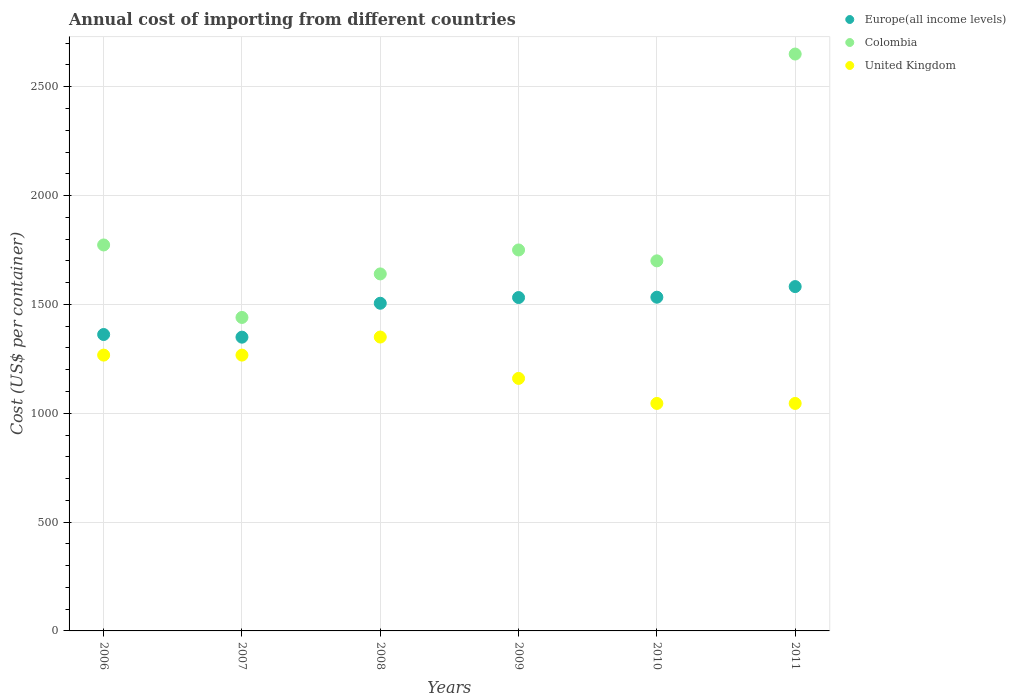How many different coloured dotlines are there?
Offer a very short reply. 3. Is the number of dotlines equal to the number of legend labels?
Your answer should be compact. Yes. What is the total annual cost of importing in Europe(all income levels) in 2009?
Make the answer very short. 1531.44. Across all years, what is the maximum total annual cost of importing in United Kingdom?
Provide a short and direct response. 1350. Across all years, what is the minimum total annual cost of importing in United Kingdom?
Keep it short and to the point. 1045. In which year was the total annual cost of importing in Colombia minimum?
Make the answer very short. 2007. What is the total total annual cost of importing in Europe(all income levels) in the graph?
Make the answer very short. 8862.38. What is the difference between the total annual cost of importing in Colombia in 2006 and that in 2011?
Keep it short and to the point. -877. What is the difference between the total annual cost of importing in United Kingdom in 2009 and the total annual cost of importing in Europe(all income levels) in 2007?
Give a very brief answer. -189.41. What is the average total annual cost of importing in Colombia per year?
Offer a terse response. 1825.5. In the year 2009, what is the difference between the total annual cost of importing in Europe(all income levels) and total annual cost of importing in United Kingdom?
Your answer should be very brief. 371.44. In how many years, is the total annual cost of importing in United Kingdom greater than 2000 US$?
Your answer should be compact. 0. What is the ratio of the total annual cost of importing in United Kingdom in 2008 to that in 2009?
Provide a succinct answer. 1.16. Is the total annual cost of importing in Europe(all income levels) in 2006 less than that in 2010?
Provide a short and direct response. Yes. What is the difference between the highest and the second highest total annual cost of importing in United Kingdom?
Provide a short and direct response. 83. What is the difference between the highest and the lowest total annual cost of importing in Europe(all income levels)?
Ensure brevity in your answer.  232.36. In how many years, is the total annual cost of importing in Colombia greater than the average total annual cost of importing in Colombia taken over all years?
Make the answer very short. 1. Does the total annual cost of importing in United Kingdom monotonically increase over the years?
Ensure brevity in your answer.  No. Is the total annual cost of importing in Europe(all income levels) strictly greater than the total annual cost of importing in Colombia over the years?
Make the answer very short. No. How many dotlines are there?
Offer a very short reply. 3. Where does the legend appear in the graph?
Keep it short and to the point. Top right. What is the title of the graph?
Ensure brevity in your answer.  Annual cost of importing from different countries. Does "Bolivia" appear as one of the legend labels in the graph?
Ensure brevity in your answer.  No. What is the label or title of the Y-axis?
Your response must be concise. Cost (US$ per container). What is the Cost (US$ per container) of Europe(all income levels) in 2006?
Keep it short and to the point. 1361.61. What is the Cost (US$ per container) of Colombia in 2006?
Provide a succinct answer. 1773. What is the Cost (US$ per container) in United Kingdom in 2006?
Keep it short and to the point. 1267. What is the Cost (US$ per container) of Europe(all income levels) in 2007?
Provide a succinct answer. 1349.41. What is the Cost (US$ per container) of Colombia in 2007?
Provide a succinct answer. 1440. What is the Cost (US$ per container) of United Kingdom in 2007?
Keep it short and to the point. 1267. What is the Cost (US$ per container) in Europe(all income levels) in 2008?
Make the answer very short. 1505.17. What is the Cost (US$ per container) in Colombia in 2008?
Make the answer very short. 1640. What is the Cost (US$ per container) in United Kingdom in 2008?
Give a very brief answer. 1350. What is the Cost (US$ per container) in Europe(all income levels) in 2009?
Offer a terse response. 1531.44. What is the Cost (US$ per container) of Colombia in 2009?
Give a very brief answer. 1750. What is the Cost (US$ per container) in United Kingdom in 2009?
Offer a terse response. 1160. What is the Cost (US$ per container) of Europe(all income levels) in 2010?
Make the answer very short. 1532.98. What is the Cost (US$ per container) of Colombia in 2010?
Your answer should be compact. 1700. What is the Cost (US$ per container) in United Kingdom in 2010?
Your response must be concise. 1045. What is the Cost (US$ per container) in Europe(all income levels) in 2011?
Provide a short and direct response. 1581.77. What is the Cost (US$ per container) in Colombia in 2011?
Provide a succinct answer. 2650. What is the Cost (US$ per container) of United Kingdom in 2011?
Give a very brief answer. 1045. Across all years, what is the maximum Cost (US$ per container) in Europe(all income levels)?
Your response must be concise. 1581.77. Across all years, what is the maximum Cost (US$ per container) of Colombia?
Keep it short and to the point. 2650. Across all years, what is the maximum Cost (US$ per container) in United Kingdom?
Offer a terse response. 1350. Across all years, what is the minimum Cost (US$ per container) of Europe(all income levels)?
Ensure brevity in your answer.  1349.41. Across all years, what is the minimum Cost (US$ per container) of Colombia?
Provide a succinct answer. 1440. Across all years, what is the minimum Cost (US$ per container) of United Kingdom?
Your answer should be very brief. 1045. What is the total Cost (US$ per container) in Europe(all income levels) in the graph?
Your response must be concise. 8862.38. What is the total Cost (US$ per container) of Colombia in the graph?
Provide a succinct answer. 1.10e+04. What is the total Cost (US$ per container) of United Kingdom in the graph?
Offer a terse response. 7134. What is the difference between the Cost (US$ per container) of Europe(all income levels) in 2006 and that in 2007?
Offer a very short reply. 12.2. What is the difference between the Cost (US$ per container) in Colombia in 2006 and that in 2007?
Offer a terse response. 333. What is the difference between the Cost (US$ per container) in United Kingdom in 2006 and that in 2007?
Your answer should be compact. 0. What is the difference between the Cost (US$ per container) of Europe(all income levels) in 2006 and that in 2008?
Offer a terse response. -143.56. What is the difference between the Cost (US$ per container) in Colombia in 2006 and that in 2008?
Offer a terse response. 133. What is the difference between the Cost (US$ per container) of United Kingdom in 2006 and that in 2008?
Offer a terse response. -83. What is the difference between the Cost (US$ per container) in Europe(all income levels) in 2006 and that in 2009?
Your answer should be very brief. -169.83. What is the difference between the Cost (US$ per container) of United Kingdom in 2006 and that in 2009?
Your answer should be very brief. 107. What is the difference between the Cost (US$ per container) in Europe(all income levels) in 2006 and that in 2010?
Ensure brevity in your answer.  -171.37. What is the difference between the Cost (US$ per container) of United Kingdom in 2006 and that in 2010?
Ensure brevity in your answer.  222. What is the difference between the Cost (US$ per container) in Europe(all income levels) in 2006 and that in 2011?
Your answer should be very brief. -220.16. What is the difference between the Cost (US$ per container) in Colombia in 2006 and that in 2011?
Keep it short and to the point. -877. What is the difference between the Cost (US$ per container) of United Kingdom in 2006 and that in 2011?
Provide a short and direct response. 222. What is the difference between the Cost (US$ per container) in Europe(all income levels) in 2007 and that in 2008?
Your response must be concise. -155.76. What is the difference between the Cost (US$ per container) of Colombia in 2007 and that in 2008?
Offer a very short reply. -200. What is the difference between the Cost (US$ per container) in United Kingdom in 2007 and that in 2008?
Your answer should be very brief. -83. What is the difference between the Cost (US$ per container) of Europe(all income levels) in 2007 and that in 2009?
Offer a terse response. -182.02. What is the difference between the Cost (US$ per container) in Colombia in 2007 and that in 2009?
Keep it short and to the point. -310. What is the difference between the Cost (US$ per container) in United Kingdom in 2007 and that in 2009?
Your response must be concise. 107. What is the difference between the Cost (US$ per container) of Europe(all income levels) in 2007 and that in 2010?
Your answer should be compact. -183.57. What is the difference between the Cost (US$ per container) of Colombia in 2007 and that in 2010?
Provide a short and direct response. -260. What is the difference between the Cost (US$ per container) of United Kingdom in 2007 and that in 2010?
Keep it short and to the point. 222. What is the difference between the Cost (US$ per container) of Europe(all income levels) in 2007 and that in 2011?
Provide a succinct answer. -232.36. What is the difference between the Cost (US$ per container) of Colombia in 2007 and that in 2011?
Give a very brief answer. -1210. What is the difference between the Cost (US$ per container) of United Kingdom in 2007 and that in 2011?
Your answer should be compact. 222. What is the difference between the Cost (US$ per container) in Europe(all income levels) in 2008 and that in 2009?
Provide a short and direct response. -26.27. What is the difference between the Cost (US$ per container) of Colombia in 2008 and that in 2009?
Provide a succinct answer. -110. What is the difference between the Cost (US$ per container) of United Kingdom in 2008 and that in 2009?
Provide a succinct answer. 190. What is the difference between the Cost (US$ per container) in Europe(all income levels) in 2008 and that in 2010?
Offer a terse response. -27.81. What is the difference between the Cost (US$ per container) of Colombia in 2008 and that in 2010?
Your answer should be compact. -60. What is the difference between the Cost (US$ per container) of United Kingdom in 2008 and that in 2010?
Keep it short and to the point. 305. What is the difference between the Cost (US$ per container) of Europe(all income levels) in 2008 and that in 2011?
Provide a short and direct response. -76.6. What is the difference between the Cost (US$ per container) of Colombia in 2008 and that in 2011?
Your answer should be compact. -1010. What is the difference between the Cost (US$ per container) of United Kingdom in 2008 and that in 2011?
Offer a very short reply. 305. What is the difference between the Cost (US$ per container) in Europe(all income levels) in 2009 and that in 2010?
Make the answer very short. -1.54. What is the difference between the Cost (US$ per container) of United Kingdom in 2009 and that in 2010?
Make the answer very short. 115. What is the difference between the Cost (US$ per container) of Europe(all income levels) in 2009 and that in 2011?
Your answer should be compact. -50.33. What is the difference between the Cost (US$ per container) of Colombia in 2009 and that in 2011?
Ensure brevity in your answer.  -900. What is the difference between the Cost (US$ per container) of United Kingdom in 2009 and that in 2011?
Offer a very short reply. 115. What is the difference between the Cost (US$ per container) in Europe(all income levels) in 2010 and that in 2011?
Your response must be concise. -48.79. What is the difference between the Cost (US$ per container) of Colombia in 2010 and that in 2011?
Make the answer very short. -950. What is the difference between the Cost (US$ per container) in Europe(all income levels) in 2006 and the Cost (US$ per container) in Colombia in 2007?
Give a very brief answer. -78.39. What is the difference between the Cost (US$ per container) in Europe(all income levels) in 2006 and the Cost (US$ per container) in United Kingdom in 2007?
Ensure brevity in your answer.  94.61. What is the difference between the Cost (US$ per container) of Colombia in 2006 and the Cost (US$ per container) of United Kingdom in 2007?
Give a very brief answer. 506. What is the difference between the Cost (US$ per container) of Europe(all income levels) in 2006 and the Cost (US$ per container) of Colombia in 2008?
Offer a terse response. -278.39. What is the difference between the Cost (US$ per container) of Europe(all income levels) in 2006 and the Cost (US$ per container) of United Kingdom in 2008?
Make the answer very short. 11.61. What is the difference between the Cost (US$ per container) of Colombia in 2006 and the Cost (US$ per container) of United Kingdom in 2008?
Your answer should be compact. 423. What is the difference between the Cost (US$ per container) of Europe(all income levels) in 2006 and the Cost (US$ per container) of Colombia in 2009?
Offer a very short reply. -388.39. What is the difference between the Cost (US$ per container) of Europe(all income levels) in 2006 and the Cost (US$ per container) of United Kingdom in 2009?
Your answer should be very brief. 201.61. What is the difference between the Cost (US$ per container) in Colombia in 2006 and the Cost (US$ per container) in United Kingdom in 2009?
Ensure brevity in your answer.  613. What is the difference between the Cost (US$ per container) in Europe(all income levels) in 2006 and the Cost (US$ per container) in Colombia in 2010?
Provide a succinct answer. -338.39. What is the difference between the Cost (US$ per container) of Europe(all income levels) in 2006 and the Cost (US$ per container) of United Kingdom in 2010?
Provide a short and direct response. 316.61. What is the difference between the Cost (US$ per container) of Colombia in 2006 and the Cost (US$ per container) of United Kingdom in 2010?
Provide a succinct answer. 728. What is the difference between the Cost (US$ per container) of Europe(all income levels) in 2006 and the Cost (US$ per container) of Colombia in 2011?
Offer a terse response. -1288.39. What is the difference between the Cost (US$ per container) in Europe(all income levels) in 2006 and the Cost (US$ per container) in United Kingdom in 2011?
Your answer should be compact. 316.61. What is the difference between the Cost (US$ per container) in Colombia in 2006 and the Cost (US$ per container) in United Kingdom in 2011?
Keep it short and to the point. 728. What is the difference between the Cost (US$ per container) in Europe(all income levels) in 2007 and the Cost (US$ per container) in Colombia in 2008?
Your response must be concise. -290.59. What is the difference between the Cost (US$ per container) in Europe(all income levels) in 2007 and the Cost (US$ per container) in United Kingdom in 2008?
Your response must be concise. -0.59. What is the difference between the Cost (US$ per container) in Europe(all income levels) in 2007 and the Cost (US$ per container) in Colombia in 2009?
Ensure brevity in your answer.  -400.59. What is the difference between the Cost (US$ per container) in Europe(all income levels) in 2007 and the Cost (US$ per container) in United Kingdom in 2009?
Offer a terse response. 189.41. What is the difference between the Cost (US$ per container) of Colombia in 2007 and the Cost (US$ per container) of United Kingdom in 2009?
Give a very brief answer. 280. What is the difference between the Cost (US$ per container) in Europe(all income levels) in 2007 and the Cost (US$ per container) in Colombia in 2010?
Offer a very short reply. -350.59. What is the difference between the Cost (US$ per container) in Europe(all income levels) in 2007 and the Cost (US$ per container) in United Kingdom in 2010?
Keep it short and to the point. 304.41. What is the difference between the Cost (US$ per container) in Colombia in 2007 and the Cost (US$ per container) in United Kingdom in 2010?
Ensure brevity in your answer.  395. What is the difference between the Cost (US$ per container) in Europe(all income levels) in 2007 and the Cost (US$ per container) in Colombia in 2011?
Give a very brief answer. -1300.59. What is the difference between the Cost (US$ per container) of Europe(all income levels) in 2007 and the Cost (US$ per container) of United Kingdom in 2011?
Offer a very short reply. 304.41. What is the difference between the Cost (US$ per container) in Colombia in 2007 and the Cost (US$ per container) in United Kingdom in 2011?
Make the answer very short. 395. What is the difference between the Cost (US$ per container) of Europe(all income levels) in 2008 and the Cost (US$ per container) of Colombia in 2009?
Ensure brevity in your answer.  -244.83. What is the difference between the Cost (US$ per container) in Europe(all income levels) in 2008 and the Cost (US$ per container) in United Kingdom in 2009?
Keep it short and to the point. 345.17. What is the difference between the Cost (US$ per container) in Colombia in 2008 and the Cost (US$ per container) in United Kingdom in 2009?
Provide a succinct answer. 480. What is the difference between the Cost (US$ per container) of Europe(all income levels) in 2008 and the Cost (US$ per container) of Colombia in 2010?
Ensure brevity in your answer.  -194.83. What is the difference between the Cost (US$ per container) in Europe(all income levels) in 2008 and the Cost (US$ per container) in United Kingdom in 2010?
Ensure brevity in your answer.  460.17. What is the difference between the Cost (US$ per container) in Colombia in 2008 and the Cost (US$ per container) in United Kingdom in 2010?
Ensure brevity in your answer.  595. What is the difference between the Cost (US$ per container) in Europe(all income levels) in 2008 and the Cost (US$ per container) in Colombia in 2011?
Ensure brevity in your answer.  -1144.83. What is the difference between the Cost (US$ per container) of Europe(all income levels) in 2008 and the Cost (US$ per container) of United Kingdom in 2011?
Offer a very short reply. 460.17. What is the difference between the Cost (US$ per container) in Colombia in 2008 and the Cost (US$ per container) in United Kingdom in 2011?
Make the answer very short. 595. What is the difference between the Cost (US$ per container) in Europe(all income levels) in 2009 and the Cost (US$ per container) in Colombia in 2010?
Ensure brevity in your answer.  -168.56. What is the difference between the Cost (US$ per container) of Europe(all income levels) in 2009 and the Cost (US$ per container) of United Kingdom in 2010?
Provide a succinct answer. 486.44. What is the difference between the Cost (US$ per container) of Colombia in 2009 and the Cost (US$ per container) of United Kingdom in 2010?
Give a very brief answer. 705. What is the difference between the Cost (US$ per container) in Europe(all income levels) in 2009 and the Cost (US$ per container) in Colombia in 2011?
Give a very brief answer. -1118.56. What is the difference between the Cost (US$ per container) in Europe(all income levels) in 2009 and the Cost (US$ per container) in United Kingdom in 2011?
Provide a short and direct response. 486.44. What is the difference between the Cost (US$ per container) of Colombia in 2009 and the Cost (US$ per container) of United Kingdom in 2011?
Make the answer very short. 705. What is the difference between the Cost (US$ per container) in Europe(all income levels) in 2010 and the Cost (US$ per container) in Colombia in 2011?
Your answer should be compact. -1117.02. What is the difference between the Cost (US$ per container) of Europe(all income levels) in 2010 and the Cost (US$ per container) of United Kingdom in 2011?
Provide a short and direct response. 487.98. What is the difference between the Cost (US$ per container) in Colombia in 2010 and the Cost (US$ per container) in United Kingdom in 2011?
Provide a succinct answer. 655. What is the average Cost (US$ per container) of Europe(all income levels) per year?
Provide a short and direct response. 1477.06. What is the average Cost (US$ per container) in Colombia per year?
Offer a terse response. 1825.5. What is the average Cost (US$ per container) of United Kingdom per year?
Make the answer very short. 1189. In the year 2006, what is the difference between the Cost (US$ per container) of Europe(all income levels) and Cost (US$ per container) of Colombia?
Provide a succinct answer. -411.39. In the year 2006, what is the difference between the Cost (US$ per container) in Europe(all income levels) and Cost (US$ per container) in United Kingdom?
Provide a succinct answer. 94.61. In the year 2006, what is the difference between the Cost (US$ per container) in Colombia and Cost (US$ per container) in United Kingdom?
Offer a terse response. 506. In the year 2007, what is the difference between the Cost (US$ per container) in Europe(all income levels) and Cost (US$ per container) in Colombia?
Make the answer very short. -90.59. In the year 2007, what is the difference between the Cost (US$ per container) of Europe(all income levels) and Cost (US$ per container) of United Kingdom?
Provide a short and direct response. 82.41. In the year 2007, what is the difference between the Cost (US$ per container) of Colombia and Cost (US$ per container) of United Kingdom?
Offer a terse response. 173. In the year 2008, what is the difference between the Cost (US$ per container) of Europe(all income levels) and Cost (US$ per container) of Colombia?
Ensure brevity in your answer.  -134.83. In the year 2008, what is the difference between the Cost (US$ per container) in Europe(all income levels) and Cost (US$ per container) in United Kingdom?
Your answer should be compact. 155.17. In the year 2008, what is the difference between the Cost (US$ per container) in Colombia and Cost (US$ per container) in United Kingdom?
Provide a succinct answer. 290. In the year 2009, what is the difference between the Cost (US$ per container) of Europe(all income levels) and Cost (US$ per container) of Colombia?
Provide a short and direct response. -218.56. In the year 2009, what is the difference between the Cost (US$ per container) of Europe(all income levels) and Cost (US$ per container) of United Kingdom?
Offer a very short reply. 371.44. In the year 2009, what is the difference between the Cost (US$ per container) in Colombia and Cost (US$ per container) in United Kingdom?
Keep it short and to the point. 590. In the year 2010, what is the difference between the Cost (US$ per container) of Europe(all income levels) and Cost (US$ per container) of Colombia?
Offer a terse response. -167.02. In the year 2010, what is the difference between the Cost (US$ per container) of Europe(all income levels) and Cost (US$ per container) of United Kingdom?
Your response must be concise. 487.98. In the year 2010, what is the difference between the Cost (US$ per container) of Colombia and Cost (US$ per container) of United Kingdom?
Your response must be concise. 655. In the year 2011, what is the difference between the Cost (US$ per container) of Europe(all income levels) and Cost (US$ per container) of Colombia?
Your response must be concise. -1068.23. In the year 2011, what is the difference between the Cost (US$ per container) of Europe(all income levels) and Cost (US$ per container) of United Kingdom?
Keep it short and to the point. 536.77. In the year 2011, what is the difference between the Cost (US$ per container) in Colombia and Cost (US$ per container) in United Kingdom?
Keep it short and to the point. 1605. What is the ratio of the Cost (US$ per container) of Europe(all income levels) in 2006 to that in 2007?
Ensure brevity in your answer.  1.01. What is the ratio of the Cost (US$ per container) in Colombia in 2006 to that in 2007?
Keep it short and to the point. 1.23. What is the ratio of the Cost (US$ per container) in Europe(all income levels) in 2006 to that in 2008?
Make the answer very short. 0.9. What is the ratio of the Cost (US$ per container) in Colombia in 2006 to that in 2008?
Provide a short and direct response. 1.08. What is the ratio of the Cost (US$ per container) of United Kingdom in 2006 to that in 2008?
Offer a very short reply. 0.94. What is the ratio of the Cost (US$ per container) in Europe(all income levels) in 2006 to that in 2009?
Make the answer very short. 0.89. What is the ratio of the Cost (US$ per container) in Colombia in 2006 to that in 2009?
Provide a short and direct response. 1.01. What is the ratio of the Cost (US$ per container) of United Kingdom in 2006 to that in 2009?
Make the answer very short. 1.09. What is the ratio of the Cost (US$ per container) in Europe(all income levels) in 2006 to that in 2010?
Provide a short and direct response. 0.89. What is the ratio of the Cost (US$ per container) of Colombia in 2006 to that in 2010?
Offer a terse response. 1.04. What is the ratio of the Cost (US$ per container) of United Kingdom in 2006 to that in 2010?
Ensure brevity in your answer.  1.21. What is the ratio of the Cost (US$ per container) in Europe(all income levels) in 2006 to that in 2011?
Your answer should be very brief. 0.86. What is the ratio of the Cost (US$ per container) in Colombia in 2006 to that in 2011?
Your response must be concise. 0.67. What is the ratio of the Cost (US$ per container) of United Kingdom in 2006 to that in 2011?
Keep it short and to the point. 1.21. What is the ratio of the Cost (US$ per container) of Europe(all income levels) in 2007 to that in 2008?
Keep it short and to the point. 0.9. What is the ratio of the Cost (US$ per container) in Colombia in 2007 to that in 2008?
Offer a very short reply. 0.88. What is the ratio of the Cost (US$ per container) in United Kingdom in 2007 to that in 2008?
Your response must be concise. 0.94. What is the ratio of the Cost (US$ per container) in Europe(all income levels) in 2007 to that in 2009?
Your answer should be very brief. 0.88. What is the ratio of the Cost (US$ per container) in Colombia in 2007 to that in 2009?
Your answer should be compact. 0.82. What is the ratio of the Cost (US$ per container) of United Kingdom in 2007 to that in 2009?
Your answer should be compact. 1.09. What is the ratio of the Cost (US$ per container) of Europe(all income levels) in 2007 to that in 2010?
Provide a short and direct response. 0.88. What is the ratio of the Cost (US$ per container) of Colombia in 2007 to that in 2010?
Offer a very short reply. 0.85. What is the ratio of the Cost (US$ per container) in United Kingdom in 2007 to that in 2010?
Your answer should be compact. 1.21. What is the ratio of the Cost (US$ per container) of Europe(all income levels) in 2007 to that in 2011?
Your answer should be compact. 0.85. What is the ratio of the Cost (US$ per container) of Colombia in 2007 to that in 2011?
Offer a terse response. 0.54. What is the ratio of the Cost (US$ per container) in United Kingdom in 2007 to that in 2011?
Offer a very short reply. 1.21. What is the ratio of the Cost (US$ per container) in Europe(all income levels) in 2008 to that in 2009?
Offer a terse response. 0.98. What is the ratio of the Cost (US$ per container) in Colombia in 2008 to that in 2009?
Offer a very short reply. 0.94. What is the ratio of the Cost (US$ per container) in United Kingdom in 2008 to that in 2009?
Keep it short and to the point. 1.16. What is the ratio of the Cost (US$ per container) of Europe(all income levels) in 2008 to that in 2010?
Provide a short and direct response. 0.98. What is the ratio of the Cost (US$ per container) of Colombia in 2008 to that in 2010?
Ensure brevity in your answer.  0.96. What is the ratio of the Cost (US$ per container) in United Kingdom in 2008 to that in 2010?
Provide a short and direct response. 1.29. What is the ratio of the Cost (US$ per container) of Europe(all income levels) in 2008 to that in 2011?
Your response must be concise. 0.95. What is the ratio of the Cost (US$ per container) of Colombia in 2008 to that in 2011?
Make the answer very short. 0.62. What is the ratio of the Cost (US$ per container) of United Kingdom in 2008 to that in 2011?
Provide a succinct answer. 1.29. What is the ratio of the Cost (US$ per container) in Europe(all income levels) in 2009 to that in 2010?
Offer a very short reply. 1. What is the ratio of the Cost (US$ per container) of Colombia in 2009 to that in 2010?
Give a very brief answer. 1.03. What is the ratio of the Cost (US$ per container) of United Kingdom in 2009 to that in 2010?
Ensure brevity in your answer.  1.11. What is the ratio of the Cost (US$ per container) in Europe(all income levels) in 2009 to that in 2011?
Make the answer very short. 0.97. What is the ratio of the Cost (US$ per container) in Colombia in 2009 to that in 2011?
Your response must be concise. 0.66. What is the ratio of the Cost (US$ per container) of United Kingdom in 2009 to that in 2011?
Your answer should be compact. 1.11. What is the ratio of the Cost (US$ per container) in Europe(all income levels) in 2010 to that in 2011?
Offer a terse response. 0.97. What is the ratio of the Cost (US$ per container) of Colombia in 2010 to that in 2011?
Your answer should be very brief. 0.64. What is the difference between the highest and the second highest Cost (US$ per container) of Europe(all income levels)?
Offer a very short reply. 48.79. What is the difference between the highest and the second highest Cost (US$ per container) in Colombia?
Offer a very short reply. 877. What is the difference between the highest and the lowest Cost (US$ per container) in Europe(all income levels)?
Your answer should be very brief. 232.36. What is the difference between the highest and the lowest Cost (US$ per container) in Colombia?
Offer a very short reply. 1210. What is the difference between the highest and the lowest Cost (US$ per container) in United Kingdom?
Your response must be concise. 305. 